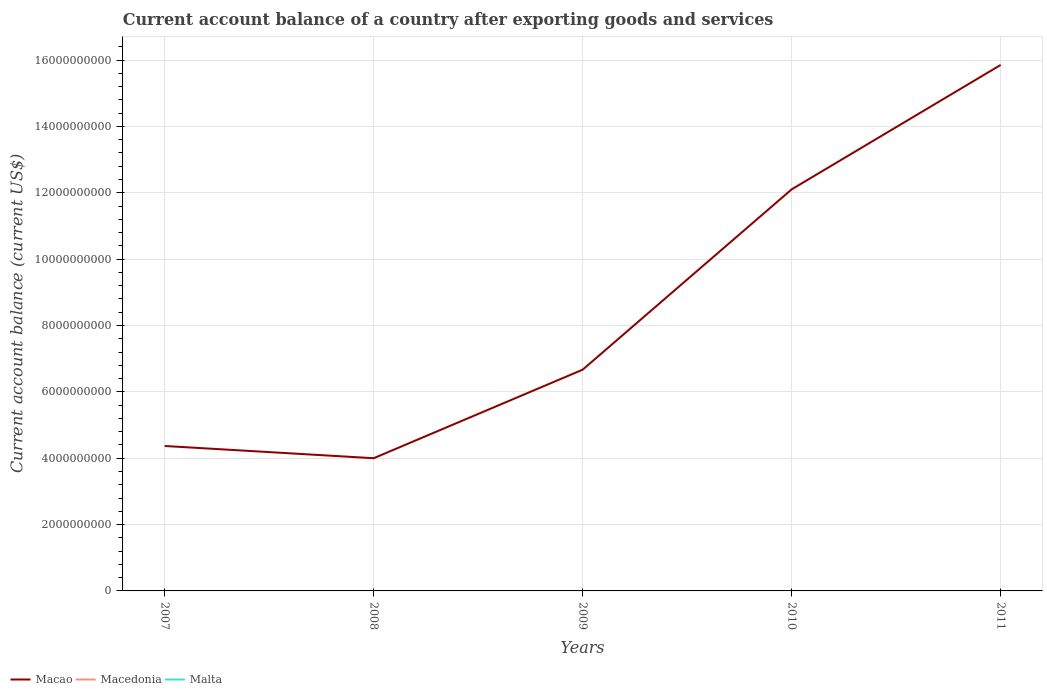Does the line corresponding to Malta intersect with the line corresponding to Macedonia?
Give a very brief answer. Yes. Across all years, what is the maximum account balance in Macedonia?
Give a very brief answer. 0. What is the total account balance in Macao in the graph?
Your answer should be compact. -5.44e+09. How many lines are there?
Your answer should be very brief. 1. Are the values on the major ticks of Y-axis written in scientific E-notation?
Provide a short and direct response. No. Does the graph contain any zero values?
Offer a terse response. Yes. Does the graph contain grids?
Keep it short and to the point. Yes. How are the legend labels stacked?
Offer a terse response. Horizontal. What is the title of the graph?
Provide a succinct answer. Current account balance of a country after exporting goods and services. Does "Cabo Verde" appear as one of the legend labels in the graph?
Give a very brief answer. No. What is the label or title of the X-axis?
Provide a short and direct response. Years. What is the label or title of the Y-axis?
Offer a terse response. Current account balance (current US$). What is the Current account balance (current US$) of Macao in 2007?
Provide a succinct answer. 4.37e+09. What is the Current account balance (current US$) in Macao in 2008?
Make the answer very short. 4.00e+09. What is the Current account balance (current US$) in Macedonia in 2008?
Offer a very short reply. 0. What is the Current account balance (current US$) of Malta in 2008?
Provide a succinct answer. 0. What is the Current account balance (current US$) of Macao in 2009?
Your answer should be very brief. 6.67e+09. What is the Current account balance (current US$) in Macedonia in 2009?
Provide a succinct answer. 0. What is the Current account balance (current US$) in Macao in 2010?
Your response must be concise. 1.21e+1. What is the Current account balance (current US$) in Malta in 2010?
Your answer should be compact. 0. What is the Current account balance (current US$) in Macao in 2011?
Ensure brevity in your answer.  1.59e+1. What is the Current account balance (current US$) in Macedonia in 2011?
Your response must be concise. 0. What is the Current account balance (current US$) of Malta in 2011?
Your answer should be compact. 0. Across all years, what is the maximum Current account balance (current US$) in Macao?
Offer a terse response. 1.59e+1. Across all years, what is the minimum Current account balance (current US$) of Macao?
Provide a short and direct response. 4.00e+09. What is the total Current account balance (current US$) of Macao in the graph?
Ensure brevity in your answer.  4.30e+1. What is the total Current account balance (current US$) of Macedonia in the graph?
Your answer should be very brief. 0. What is the total Current account balance (current US$) in Malta in the graph?
Your answer should be compact. 0. What is the difference between the Current account balance (current US$) in Macao in 2007 and that in 2008?
Keep it short and to the point. 3.69e+08. What is the difference between the Current account balance (current US$) of Macao in 2007 and that in 2009?
Make the answer very short. -2.30e+09. What is the difference between the Current account balance (current US$) of Macao in 2007 and that in 2010?
Offer a very short reply. -7.74e+09. What is the difference between the Current account balance (current US$) of Macao in 2007 and that in 2011?
Keep it short and to the point. -1.15e+1. What is the difference between the Current account balance (current US$) in Macao in 2008 and that in 2009?
Provide a succinct answer. -2.67e+09. What is the difference between the Current account balance (current US$) of Macao in 2008 and that in 2010?
Make the answer very short. -8.10e+09. What is the difference between the Current account balance (current US$) in Macao in 2008 and that in 2011?
Provide a short and direct response. -1.19e+1. What is the difference between the Current account balance (current US$) of Macao in 2009 and that in 2010?
Ensure brevity in your answer.  -5.44e+09. What is the difference between the Current account balance (current US$) in Macao in 2009 and that in 2011?
Give a very brief answer. -9.18e+09. What is the difference between the Current account balance (current US$) of Macao in 2010 and that in 2011?
Your answer should be very brief. -3.75e+09. What is the average Current account balance (current US$) in Macao per year?
Provide a succinct answer. 8.60e+09. What is the average Current account balance (current US$) of Macedonia per year?
Give a very brief answer. 0. What is the average Current account balance (current US$) of Malta per year?
Your answer should be very brief. 0. What is the ratio of the Current account balance (current US$) in Macao in 2007 to that in 2008?
Ensure brevity in your answer.  1.09. What is the ratio of the Current account balance (current US$) in Macao in 2007 to that in 2009?
Keep it short and to the point. 0.66. What is the ratio of the Current account balance (current US$) of Macao in 2007 to that in 2010?
Your answer should be very brief. 0.36. What is the ratio of the Current account balance (current US$) in Macao in 2007 to that in 2011?
Your answer should be very brief. 0.28. What is the ratio of the Current account balance (current US$) in Macao in 2008 to that in 2009?
Your answer should be very brief. 0.6. What is the ratio of the Current account balance (current US$) in Macao in 2008 to that in 2010?
Keep it short and to the point. 0.33. What is the ratio of the Current account balance (current US$) in Macao in 2008 to that in 2011?
Ensure brevity in your answer.  0.25. What is the ratio of the Current account balance (current US$) of Macao in 2009 to that in 2010?
Make the answer very short. 0.55. What is the ratio of the Current account balance (current US$) of Macao in 2009 to that in 2011?
Provide a succinct answer. 0.42. What is the ratio of the Current account balance (current US$) in Macao in 2010 to that in 2011?
Offer a terse response. 0.76. What is the difference between the highest and the second highest Current account balance (current US$) of Macao?
Provide a succinct answer. 3.75e+09. What is the difference between the highest and the lowest Current account balance (current US$) of Macao?
Make the answer very short. 1.19e+1. 